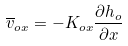Convert formula to latex. <formula><loc_0><loc_0><loc_500><loc_500>\overline { v } _ { o x } = - K _ { o x } \frac { \partial h _ { o } } { \partial x }</formula> 